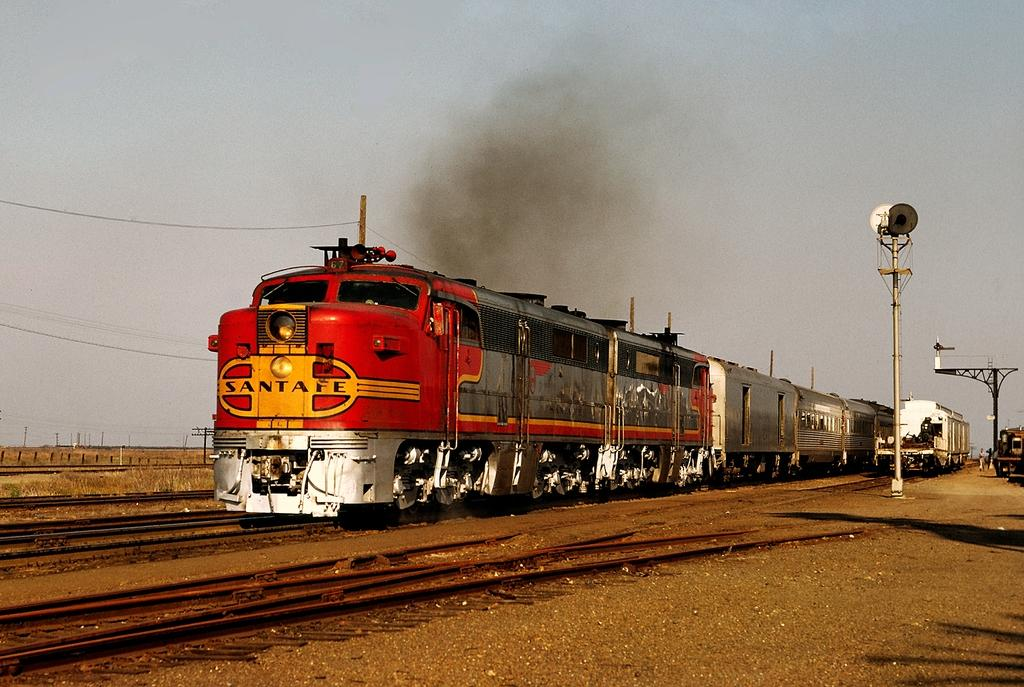What is the main subject of the image? The main subject of the image is a train on railway tracks. What can be seen in the background of the image? In the background of the image, there are poles, smoke, wires, shadows, and the sky. What is the train's position in relation to the railway tracks? The train is on the railway tracks in the image. What type of veil is draped over the train in the image? There is no veil present in the image; it features a train on railway tracks with various elements in the background. 